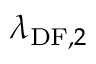<formula> <loc_0><loc_0><loc_500><loc_500>\lambda _ { D F , 2 }</formula> 